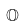<formula> <loc_0><loc_0><loc_500><loc_500>\mathbb { O }</formula> 